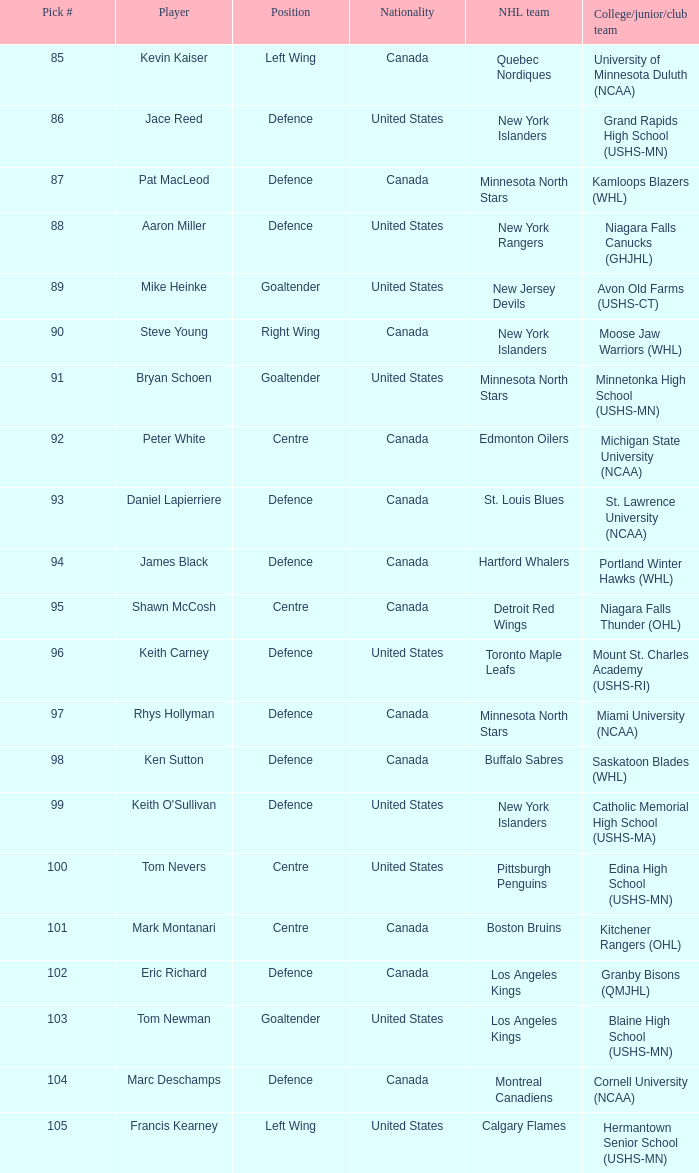What pick number was marc deschamps? 104.0. 